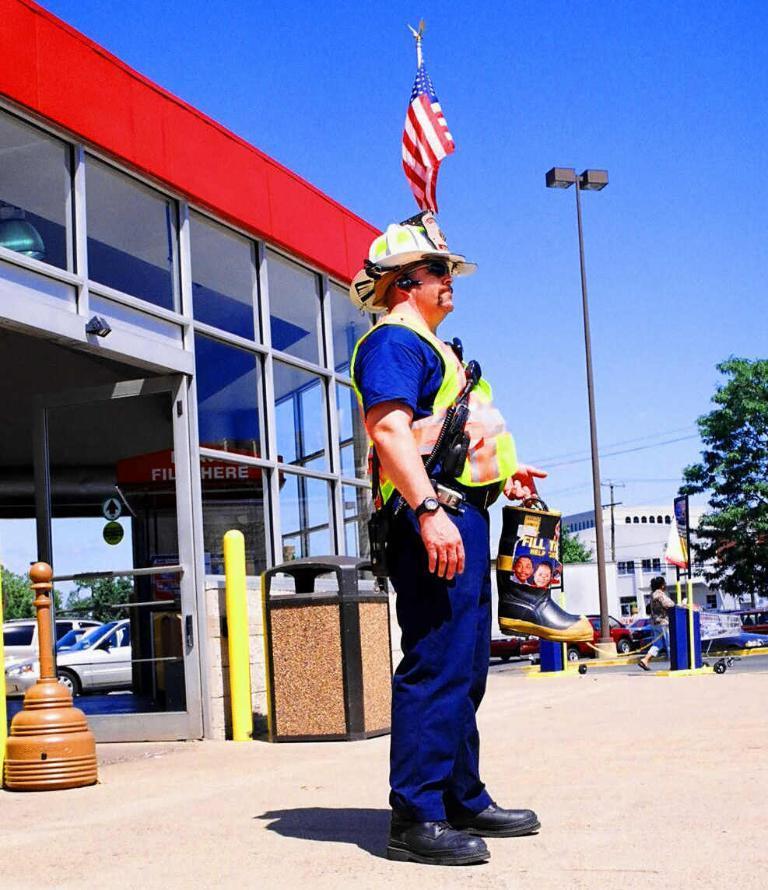How would you summarize this image in a sentence or two? In this image, we can see a man is holding some object and wearing a hat. He is standing on the walkway. Background we can see few houses, glass objects, door, poles, dustbin, vehicles, trees, banners and sky. Here there is a flag. On the right side of the image, we can see a person is walking. 